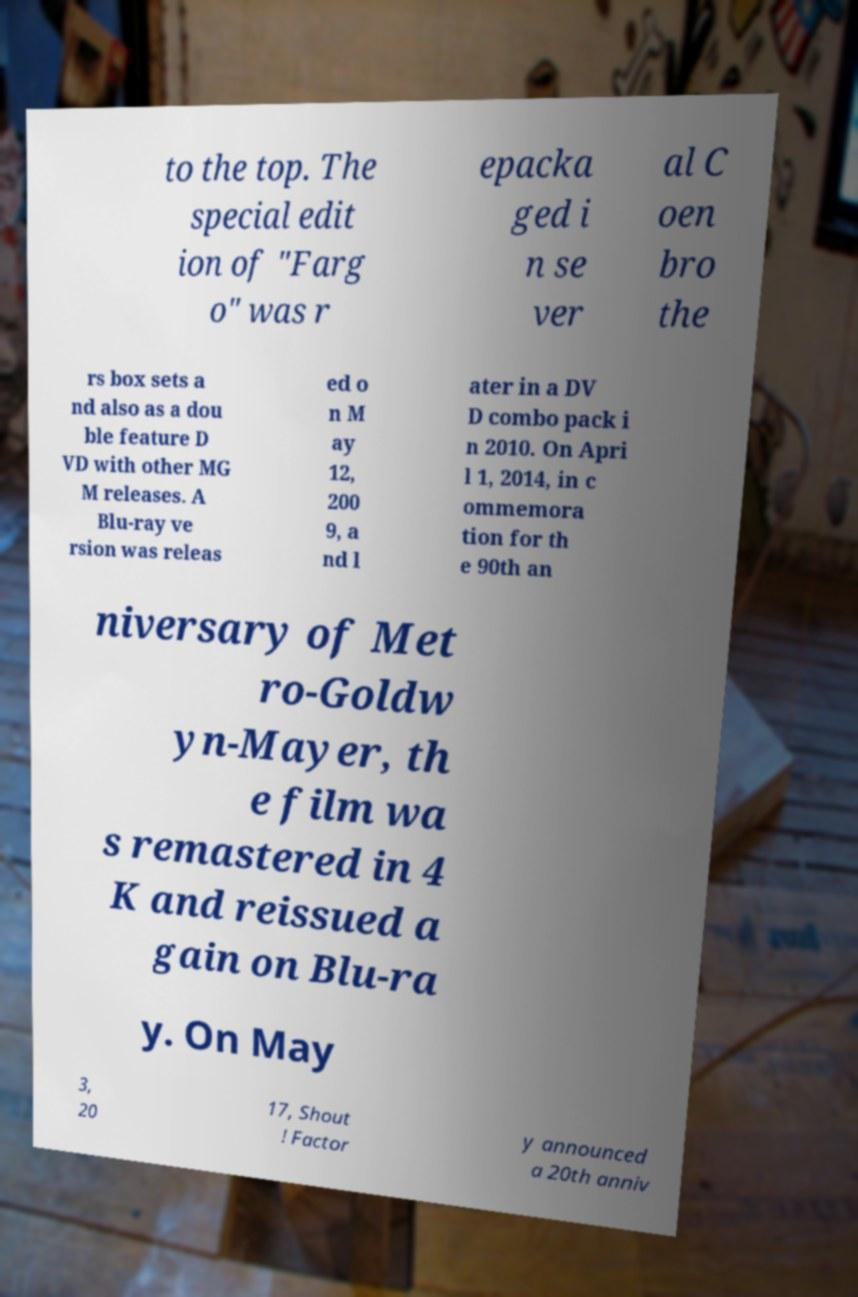What messages or text are displayed in this image? I need them in a readable, typed format. to the top. The special edit ion of "Farg o" was r epacka ged i n se ver al C oen bro the rs box sets a nd also as a dou ble feature D VD with other MG M releases. A Blu-ray ve rsion was releas ed o n M ay 12, 200 9, a nd l ater in a DV D combo pack i n 2010. On Apri l 1, 2014, in c ommemora tion for th e 90th an niversary of Met ro-Goldw yn-Mayer, th e film wa s remastered in 4 K and reissued a gain on Blu-ra y. On May 3, 20 17, Shout ! Factor y announced a 20th anniv 